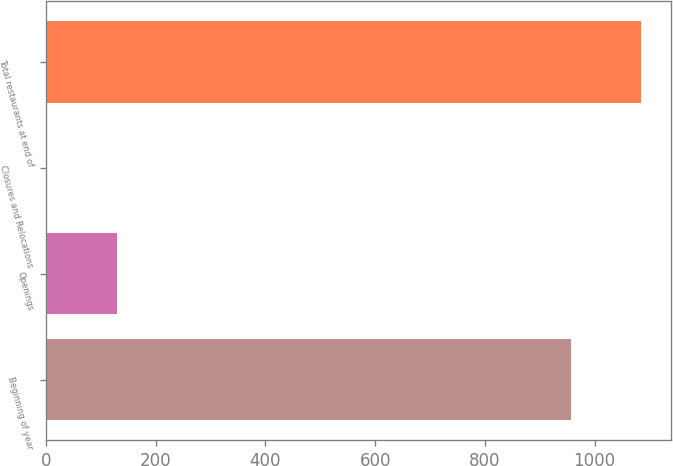Convert chart. <chart><loc_0><loc_0><loc_500><loc_500><bar_chart><fcel>Beginning of year<fcel>Openings<fcel>Closures and Relocations<fcel>Total restaurants at end of<nl><fcel>956<fcel>129<fcel>1<fcel>1084<nl></chart> 